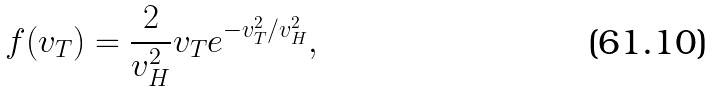Convert formula to latex. <formula><loc_0><loc_0><loc_500><loc_500>f ( v _ { T } ) = \frac { 2 } { v _ { H } ^ { 2 } } v _ { T } e ^ { - v ^ { 2 } _ { T } / v _ { H } ^ { 2 } } ,</formula> 